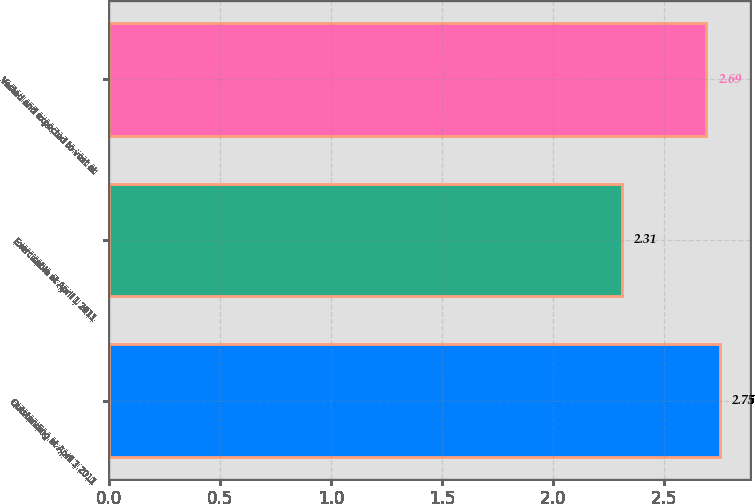<chart> <loc_0><loc_0><loc_500><loc_500><bar_chart><fcel>Outstanding at April 1 2011<fcel>Exercisable at April 1 2011<fcel>Vested and expected to vest at<nl><fcel>2.75<fcel>2.31<fcel>2.69<nl></chart> 